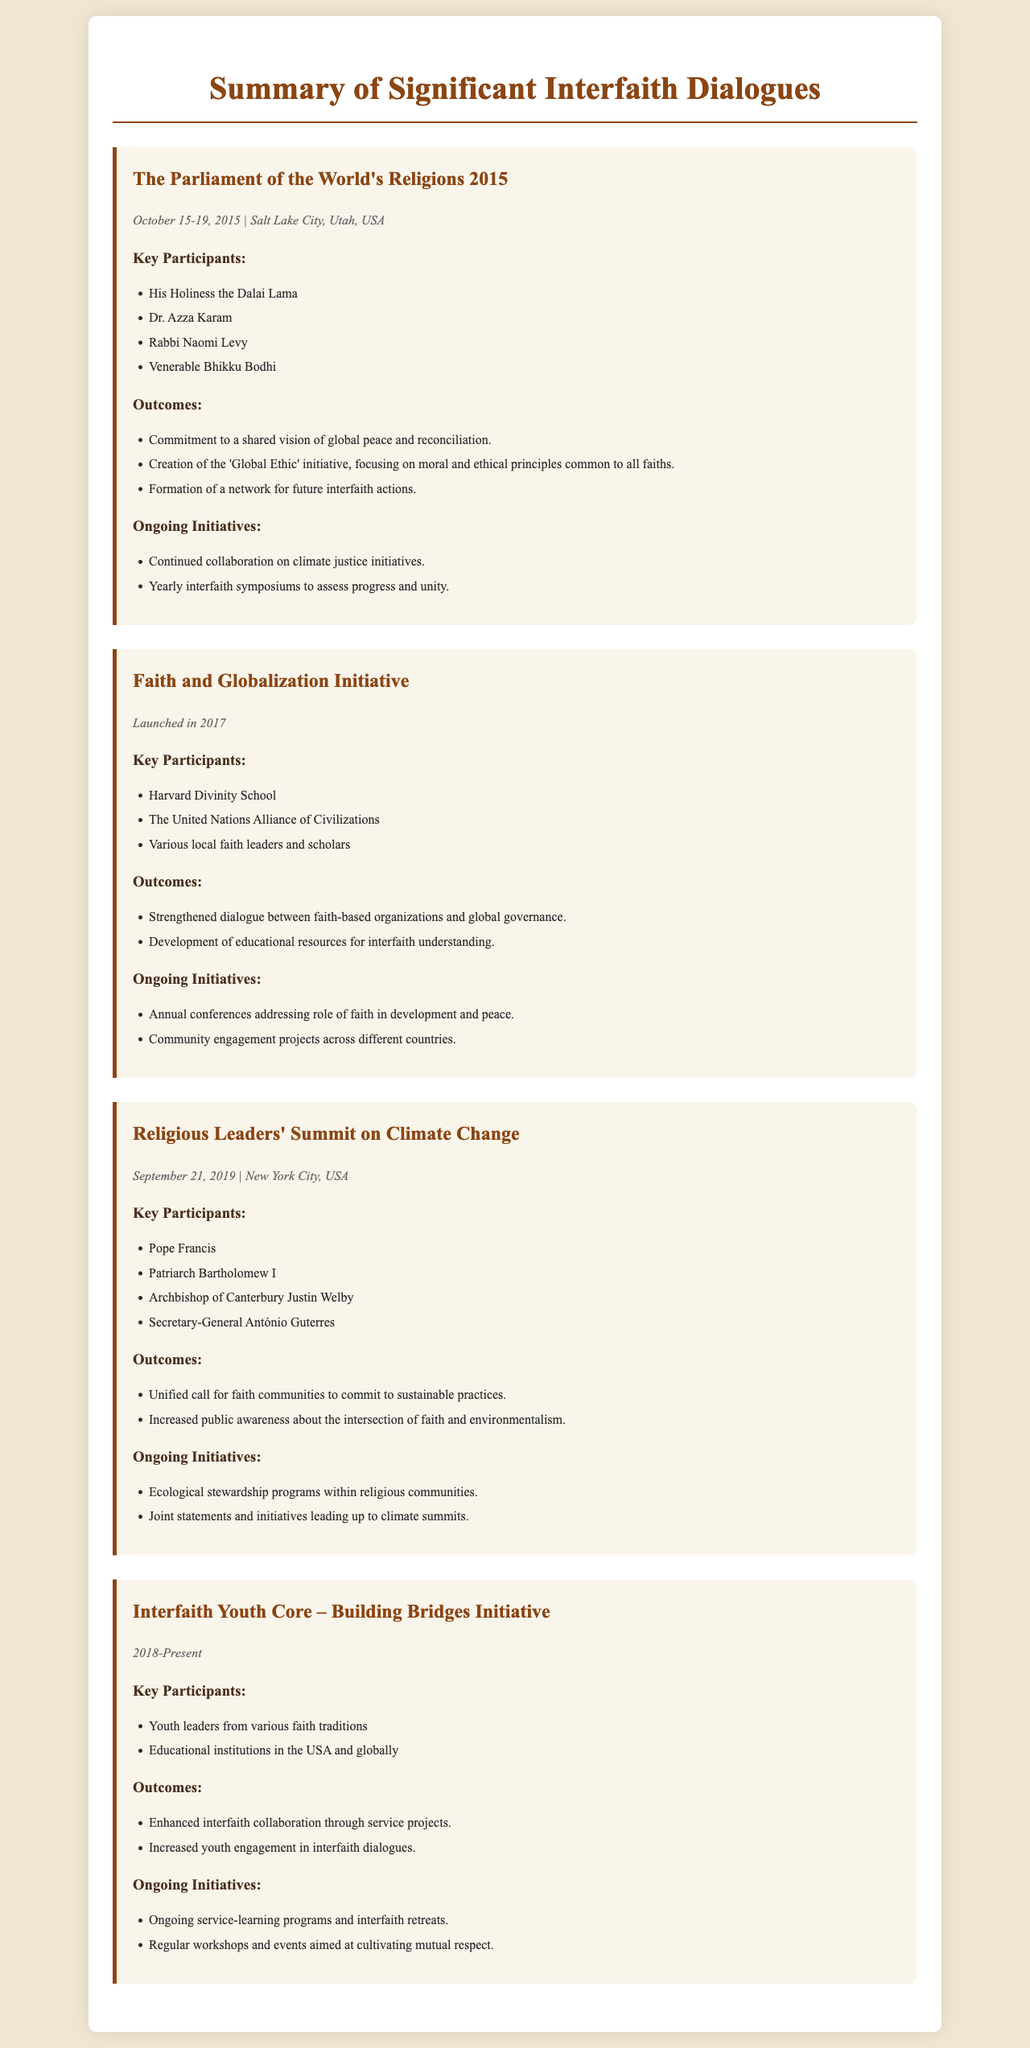What event took place in 2015? The document mentions "The Parliament of the World's Religions 2015" as an event held in 2015.
Answer: The Parliament of the World's Religions 2015 Who was a participant at the Religious Leaders' Summit on Climate Change? The document lists key participants of this summit, including Pope Francis.
Answer: Pope Francis What initiative focuses on youth leadership from various faith traditions? The document describes the "Interfaith Youth Core – Building Bridges Initiative" as focusing on youth leaders.
Answer: Interfaith Youth Core – Building Bridges Initiative What was a key outcome of the Faith and Globalization Initiative? The document states that a key outcome was the strengthening of dialogue between faith-based organizations and global governance.
Answer: Strengthened dialogue How many days did the Parliament of the World's Religions last? The document specifies the event lasted from October 15-19, 2015, totaling five days.
Answer: Five days What is one ongoing initiative from the Religious Leaders' Summit on Climate Change? The document mentions "Ecological stewardship programs within religious communities" as an ongoing initiative.
Answer: Ecological stewardship programs Which organization is involved in the Faith and Globalization Initiative? The document lists the "United Nations Alliance of Civilizations" as part of this initiative.
Answer: United Nations Alliance of Civilizations What year was the Interfaith Youth Core initiative established? The document states the Interfaith Youth Core has been active from 2018 to the present.
Answer: 2018 What moral principle is a focus of the 'Global Ethic' initiative? The document mentions it focuses on moral and ethical principles common to all faiths.
Answer: Moral and ethical principles common to all faiths 